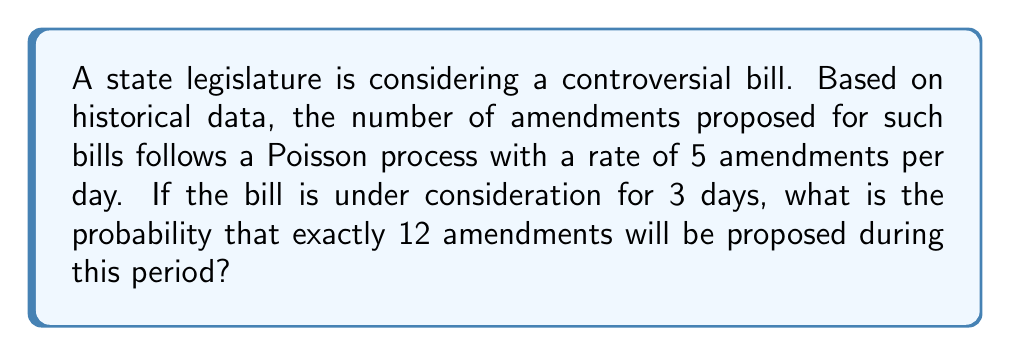Give your solution to this math problem. To solve this problem, we'll use the Poisson distribution formula:

$$P(X = k) = \frac{e^{-\lambda} \lambda^k}{k!}$$

Where:
- $X$ is the number of events (amendments in this case)
- $k$ is the specific number of events we're interested in (12 amendments)
- $\lambda$ is the average number of events in the given time period

Step 1: Calculate $\lambda$
- Rate of amendments: 5 per day
- Time period: 3 days
- $\lambda = 5 \times 3 = 15$

Step 2: Apply the Poisson distribution formula
$$P(X = 12) = \frac{e^{-15} 15^{12}}{12!}$$

Step 3: Calculate the result
$$P(X = 12) = \frac{e^{-15} \times 15^{12}}{12!} \approx 0.0976$$

This can be computed using a calculator or programming language with support for exponentials and factorials.
Answer: $0.0976$ or $9.76\%$ 